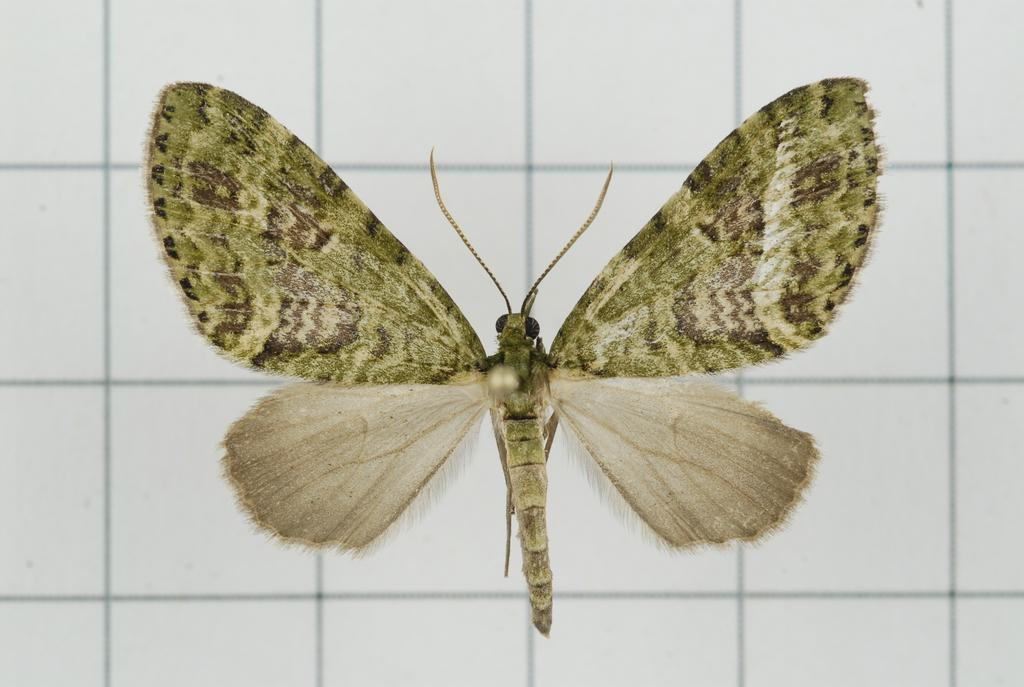What type of creature is present in the image? There is an insect in the image. What is the background or surface on which the insect is located? The insect is on white color tiles. What type of sheet is covering the insect in the image? There is no sheet covering the insect in the image; it is on white color tiles. 